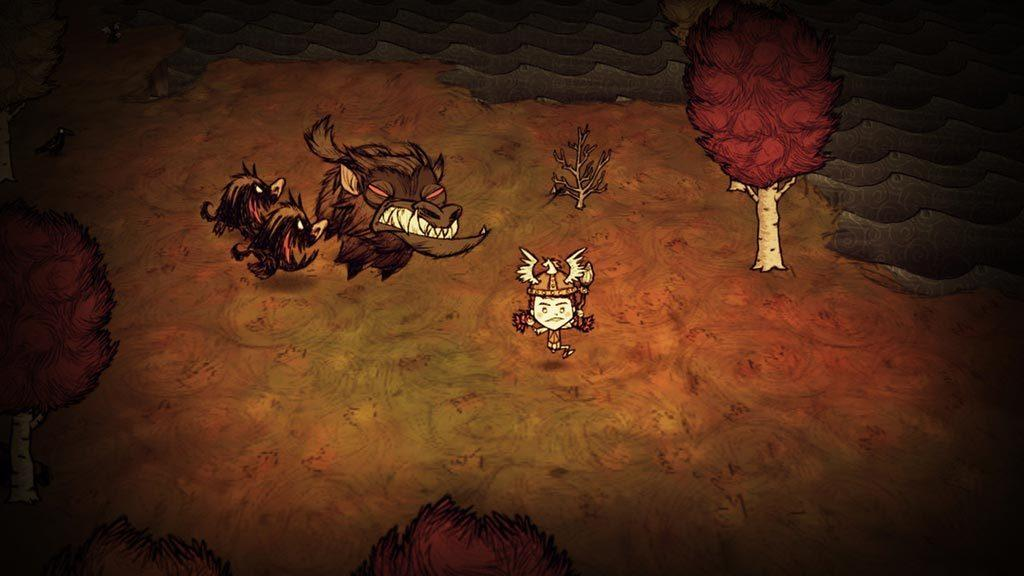What type of paintings are present in the image? The image contains paintings of trees, animals, and grass, as well as a painting of a person. What is the overall appearance of the image? The image appears to be a graphical image. Can you tell me how many times the person in the painting slips on the grass? There is no indication in the image that the person in the painting slips on the grass, as it is a graphical representation of a person and not an actual scene. 